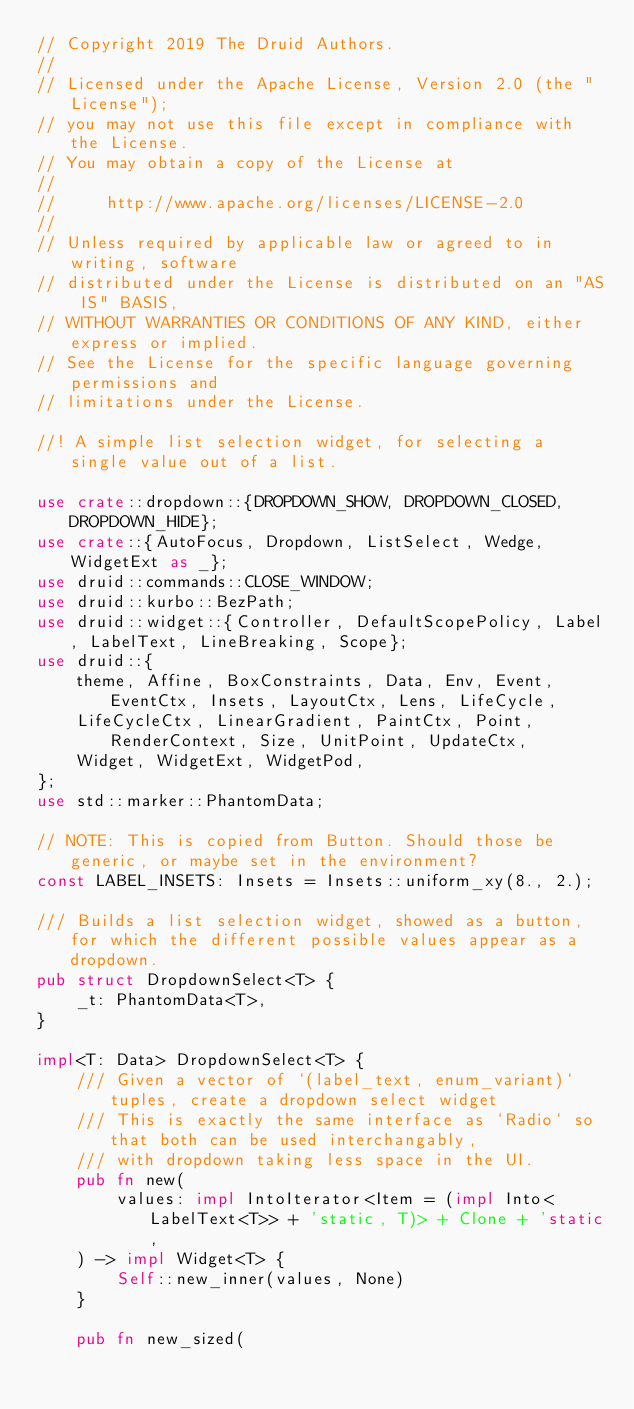<code> <loc_0><loc_0><loc_500><loc_500><_Rust_>// Copyright 2019 The Druid Authors.
//
// Licensed under the Apache License, Version 2.0 (the "License");
// you may not use this file except in compliance with the License.
// You may obtain a copy of the License at
//
//     http://www.apache.org/licenses/LICENSE-2.0
//
// Unless required by applicable law or agreed to in writing, software
// distributed under the License is distributed on an "AS IS" BASIS,
// WITHOUT WARRANTIES OR CONDITIONS OF ANY KIND, either express or implied.
// See the License for the specific language governing permissions and
// limitations under the License.

//! A simple list selection widget, for selecting a single value out of a list.

use crate::dropdown::{DROPDOWN_SHOW, DROPDOWN_CLOSED, DROPDOWN_HIDE};
use crate::{AutoFocus, Dropdown, ListSelect, Wedge, WidgetExt as _};
use druid::commands::CLOSE_WINDOW;
use druid::kurbo::BezPath;
use druid::widget::{Controller, DefaultScopePolicy, Label, LabelText, LineBreaking, Scope};
use druid::{
    theme, Affine, BoxConstraints, Data, Env, Event, EventCtx, Insets, LayoutCtx, Lens, LifeCycle,
    LifeCycleCtx, LinearGradient, PaintCtx, Point, RenderContext, Size, UnitPoint, UpdateCtx,
    Widget, WidgetExt, WidgetPod,
};
use std::marker::PhantomData;

// NOTE: This is copied from Button. Should those be generic, or maybe set in the environment?
const LABEL_INSETS: Insets = Insets::uniform_xy(8., 2.);

/// Builds a list selection widget, showed as a button, for which the different possible values appear as a dropdown.
pub struct DropdownSelect<T> {
    _t: PhantomData<T>,
}

impl<T: Data> DropdownSelect<T> {
    /// Given a vector of `(label_text, enum_variant)` tuples, create a dropdown select widget
    /// This is exactly the same interface as `Radio` so that both can be used interchangably,
    /// with dropdown taking less space in the UI.
    pub fn new(
        values: impl IntoIterator<Item = (impl Into<LabelText<T>> + 'static, T)> + Clone + 'static,
    ) -> impl Widget<T> {
        Self::new_inner(values, None)
    }

    pub fn new_sized(</code> 